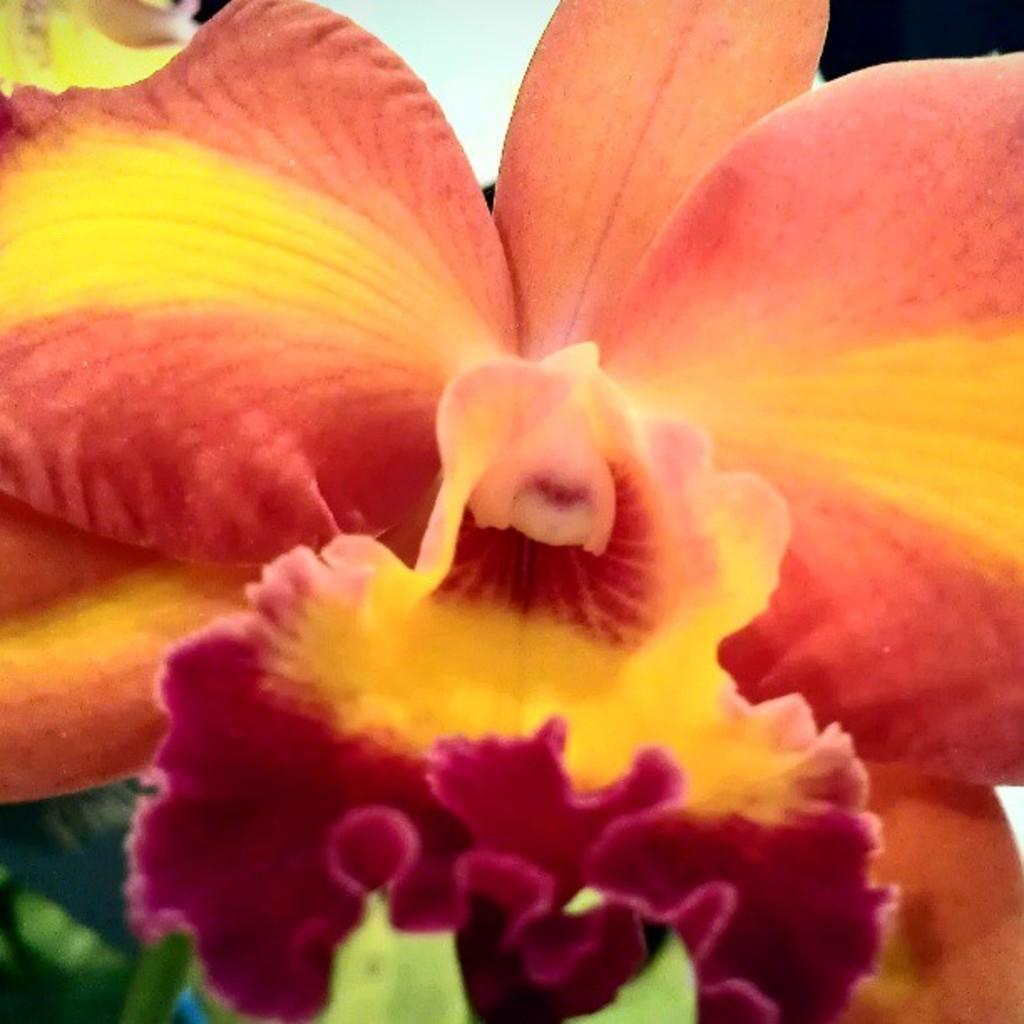In one or two sentences, can you explain what this image depicts? In this image there is a flower. 